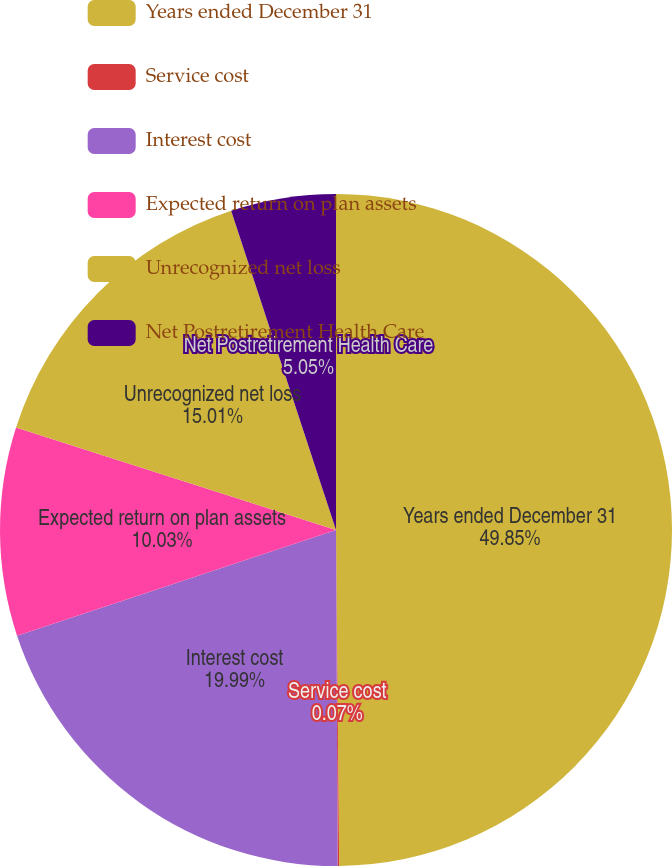Convert chart. <chart><loc_0><loc_0><loc_500><loc_500><pie_chart><fcel>Years ended December 31<fcel>Service cost<fcel>Interest cost<fcel>Expected return on plan assets<fcel>Unrecognized net loss<fcel>Net Postretirement Health Care<nl><fcel>49.85%<fcel>0.07%<fcel>19.99%<fcel>10.03%<fcel>15.01%<fcel>5.05%<nl></chart> 